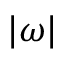<formula> <loc_0><loc_0><loc_500><loc_500>| \boldsymbol \omega |</formula> 